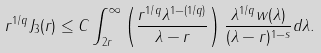<formula> <loc_0><loc_0><loc_500><loc_500>r ^ { 1 / q } J _ { 3 } ( r ) \leq C \int _ { 2 r } ^ { \infty } \left ( \frac { r ^ { 1 / q } \lambda ^ { 1 - ( 1 / q ) } } { \lambda - r } \right ) \frac { \lambda ^ { 1 / q } w ( \lambda ) } { ( \lambda - r ) ^ { 1 - s } } d \lambda .</formula> 